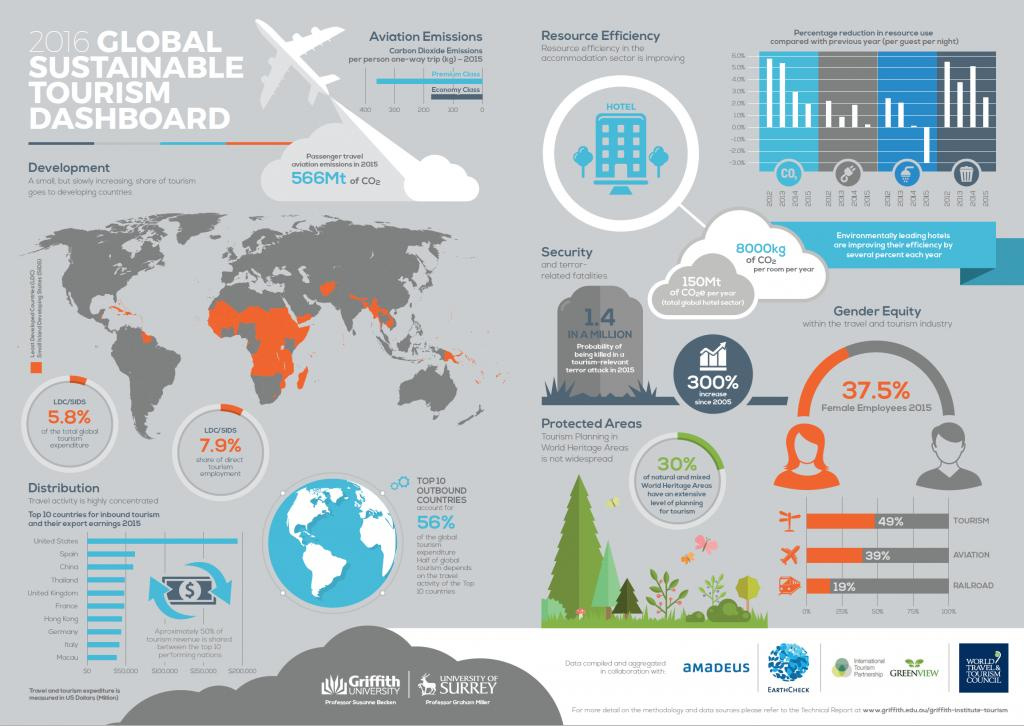Point out several critical features in this image. The two flight classes mentioned are premium class and economy class. In 2015, the percentage of female employees in the travel and tourism industry was 37.5%. According to a recent study, only 39% of the aviation industry is comprised of females. According to a recent survey of the railroad industry, it was found that 81% of employees in this sector are male. The probability of being killed in a terrorist attack related to tourism has increased by 300% since 2005. 